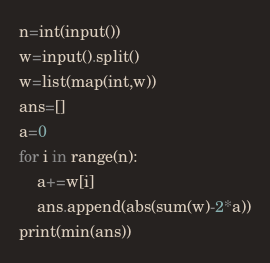<code> <loc_0><loc_0><loc_500><loc_500><_Python_>n=int(input())
w=input().split()
w=list(map(int,w))
ans=[]
a=0
for i in range(n):
    a+=w[i]
    ans.append(abs(sum(w)-2*a))
print(min(ans))</code> 